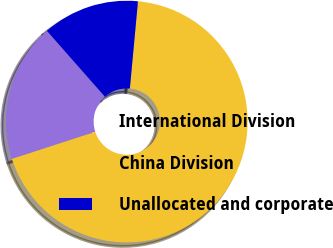Convert chart to OTSL. <chart><loc_0><loc_0><loc_500><loc_500><pie_chart><fcel>International Division<fcel>China Division<fcel>Unallocated and corporate<nl><fcel>18.52%<fcel>68.52%<fcel>12.96%<nl></chart> 